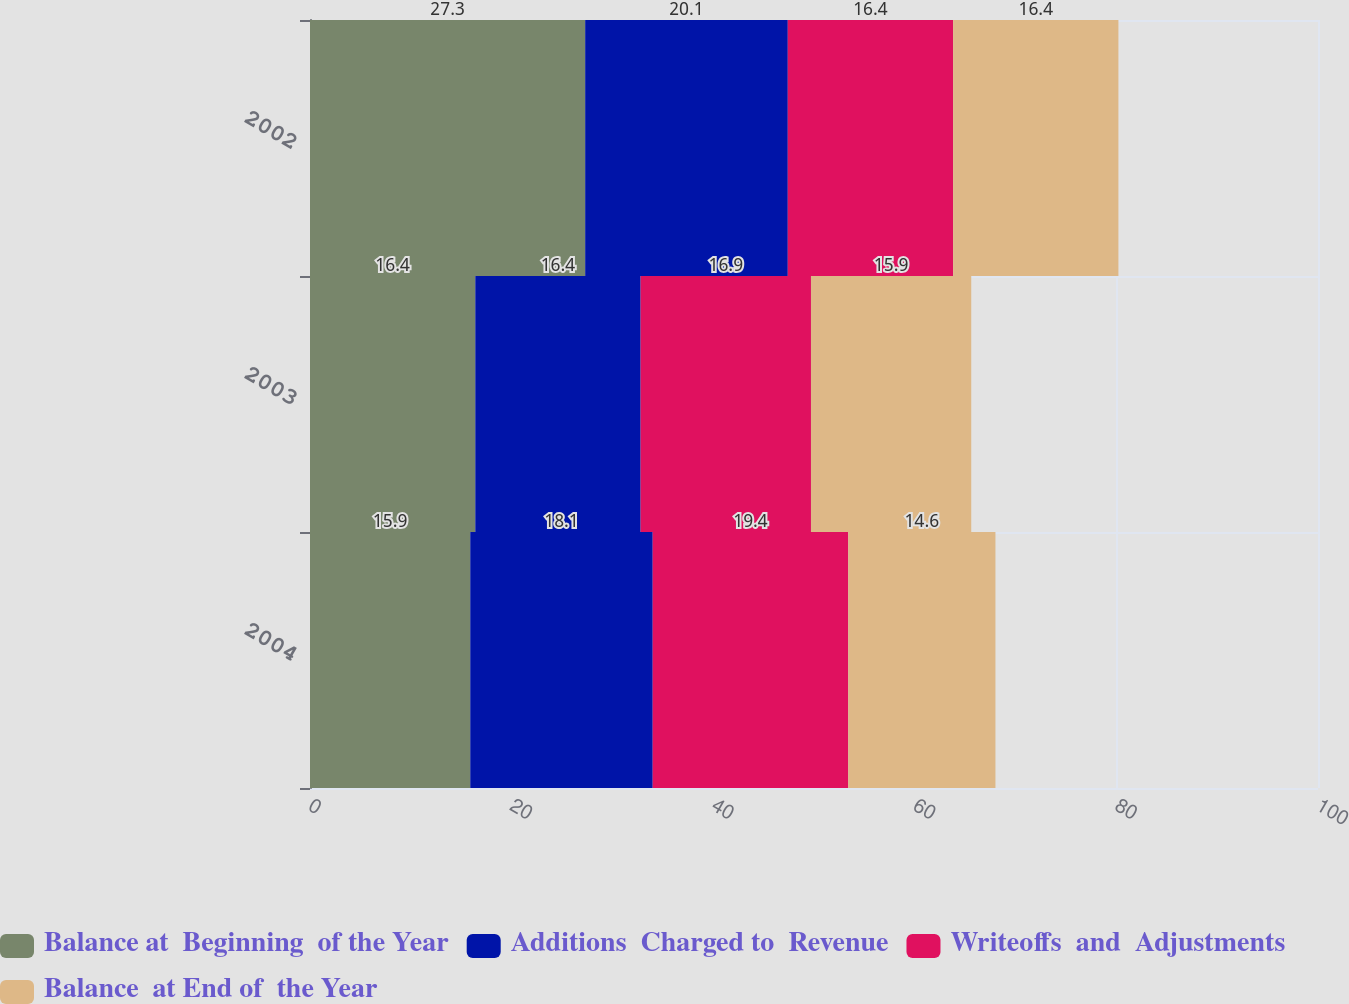<chart> <loc_0><loc_0><loc_500><loc_500><stacked_bar_chart><ecel><fcel>2004<fcel>2003<fcel>2002<nl><fcel>Balance at  Beginning  of the Year<fcel>15.9<fcel>16.4<fcel>27.3<nl><fcel>Additions  Charged to  Revenue<fcel>18.1<fcel>16.4<fcel>20.1<nl><fcel>Writeoffs  and  Adjustments<fcel>19.4<fcel>16.9<fcel>16.4<nl><fcel>Balance  at End of  the Year<fcel>14.6<fcel>15.9<fcel>16.4<nl></chart> 